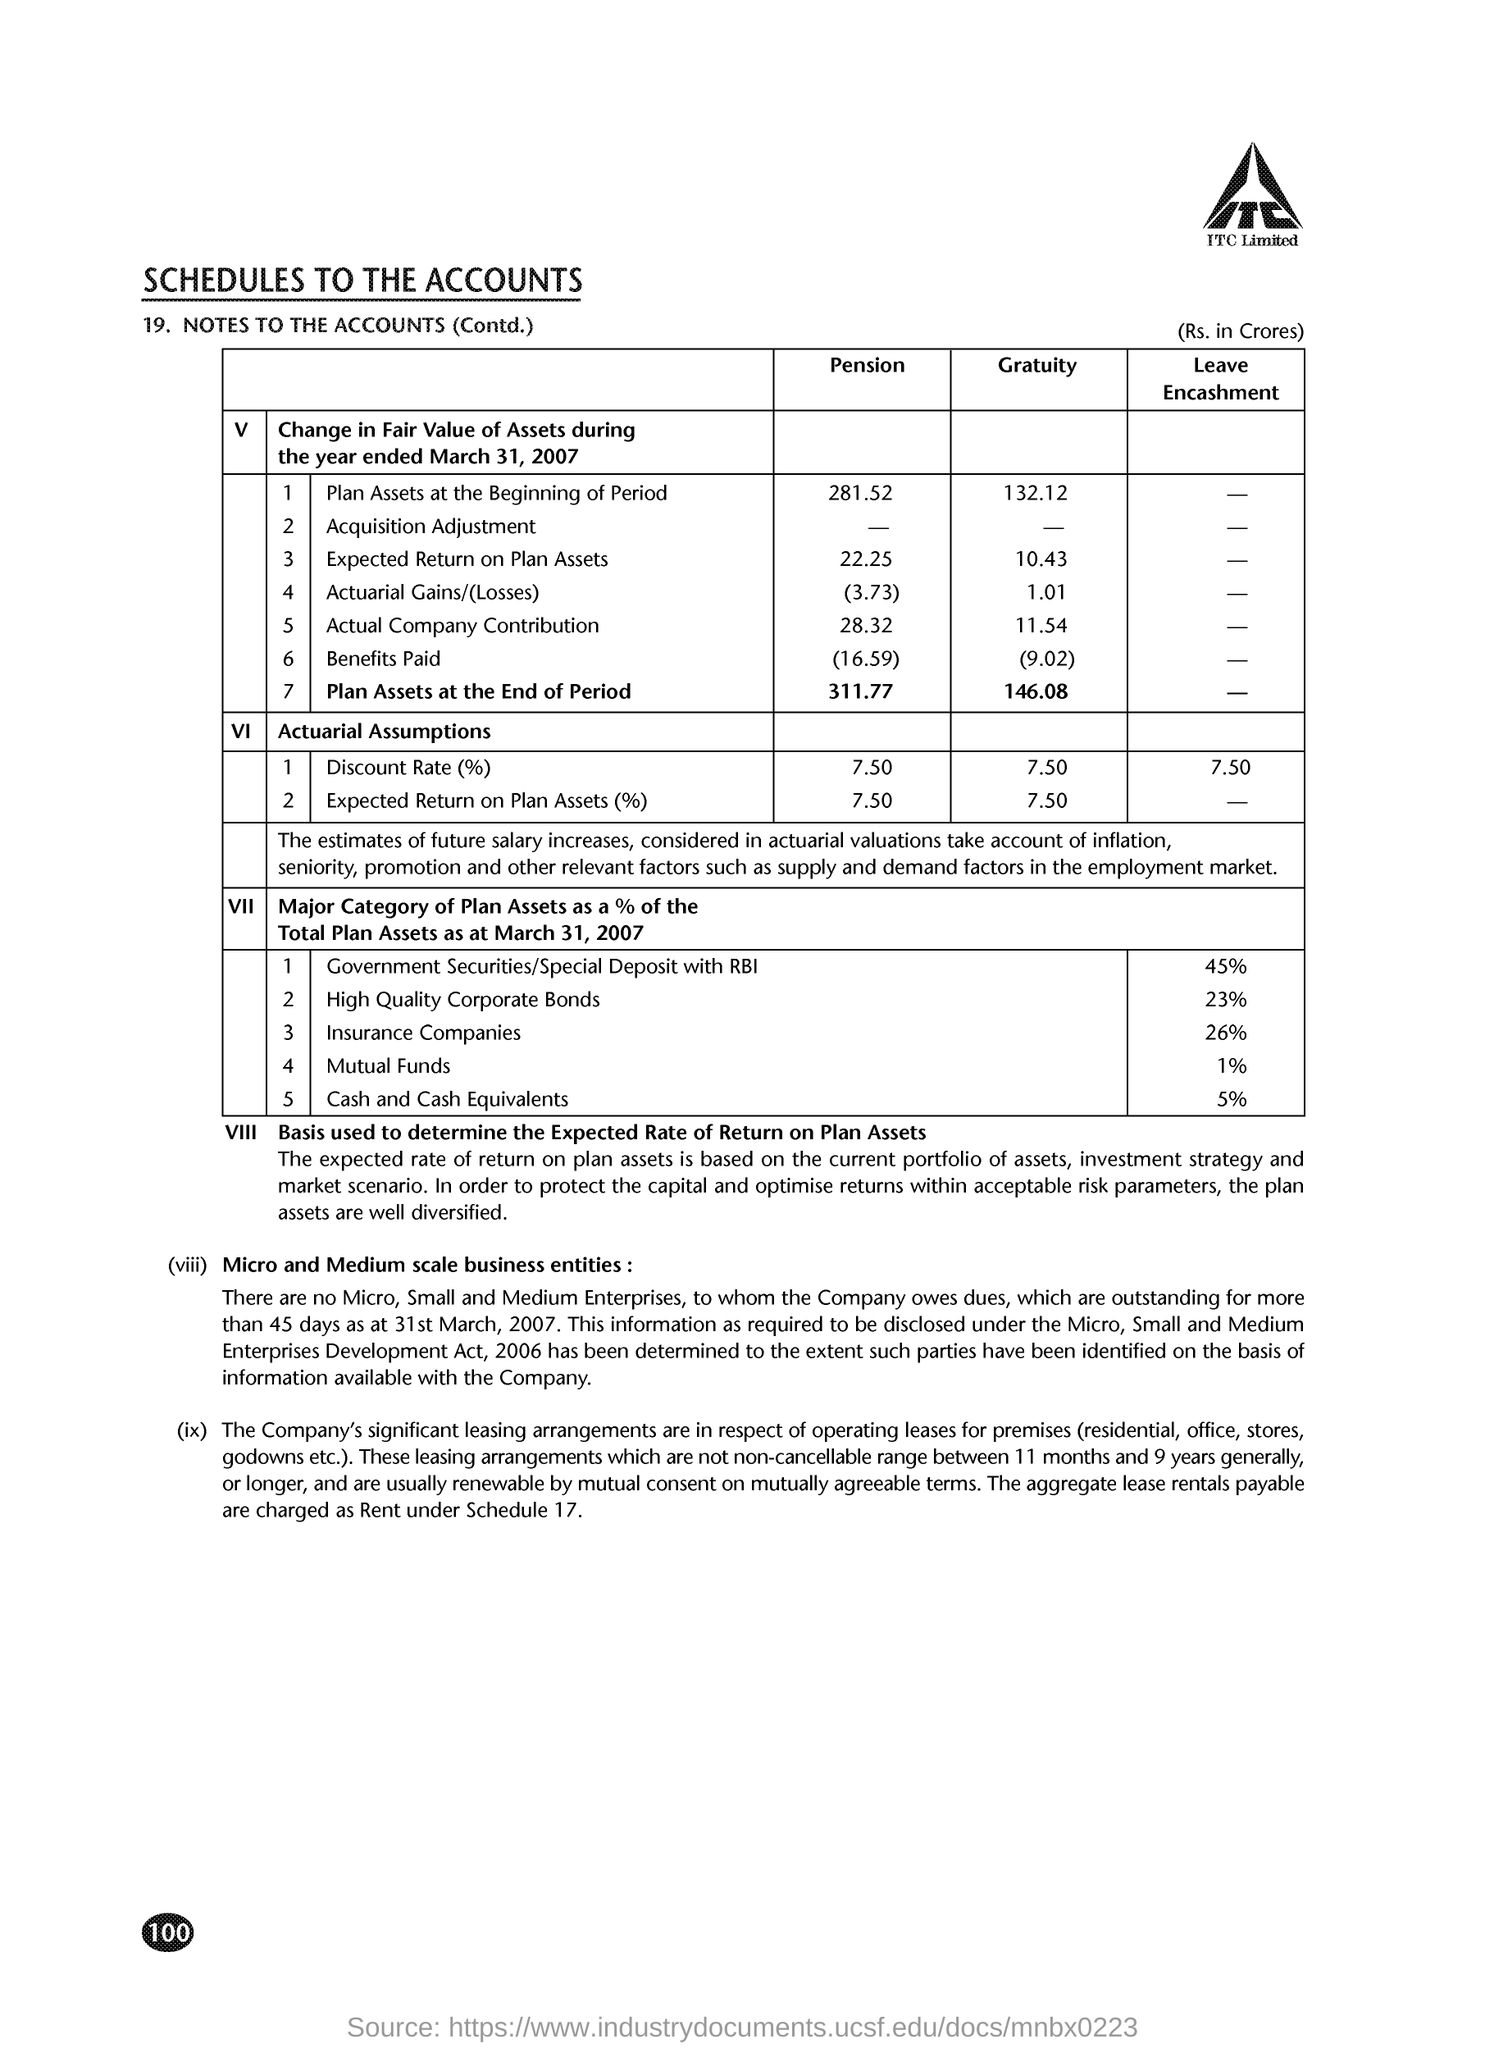Point out several critical features in this image. The plan assets at the beginning of the pension period were 281.52. 